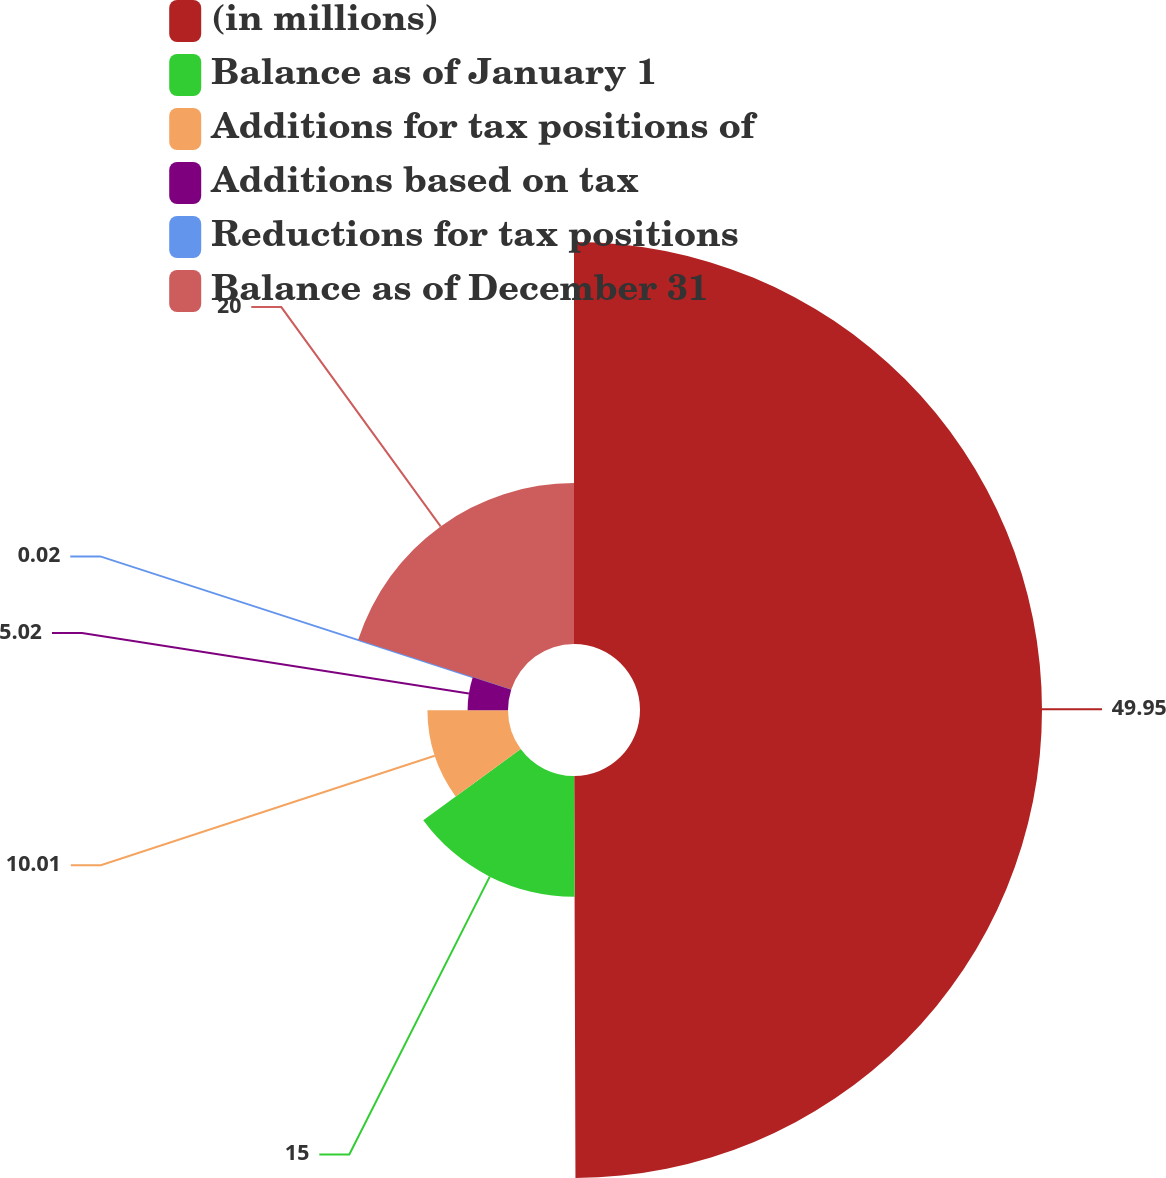Convert chart to OTSL. <chart><loc_0><loc_0><loc_500><loc_500><pie_chart><fcel>(in millions)<fcel>Balance as of January 1<fcel>Additions for tax positions of<fcel>Additions based on tax<fcel>Reductions for tax positions<fcel>Balance as of December 31<nl><fcel>49.95%<fcel>15.0%<fcel>10.01%<fcel>5.02%<fcel>0.02%<fcel>20.0%<nl></chart> 